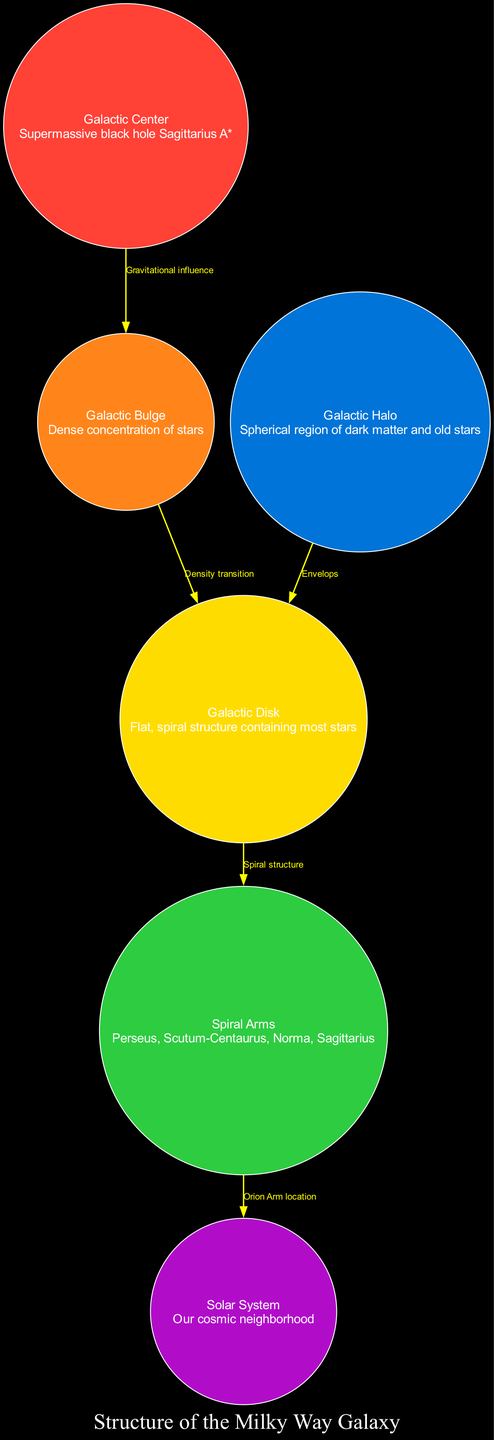What is located at the Galactic Center? The diagram indicates that the Galactic Center is home to the supermassive black hole Sagittarius A*. This information is directly included in the description of the Galactic Center node.
Answer: Sagittarius A* What is the relationship between the Galactic Bulge and the Galactic Disk? The edge between the Galactic Bulge and the Galactic Disk is labeled "Density transition," signifying a shift in star density from the bulge to the disk. This shows how the structures are connected in terms of star distribution.
Answer: Density transition How many spiral arms are indicated in the diagram? The diagram specifically lists four spiral arms: Perseus, Scutum-Centaurus, Norma, and Sagittarius. Counting these gives the total number of spiral arms present in the Milky Way structure.
Answer: Four What color represents the Galactic Halo? Referring to the color coding in the diagram, the Galactic Halo is represented in blue. This is confirmed by identifying its corresponding node color.
Answer: Blue Which component of the Milky Way contains our Solar System? According to the diagram, the Solar System is located within the Solar System node, which is specifically labeled and described as our cosmic neighborhood.
Answer: Solar System What influences the Galactic Bulge? The diagram shows an edge labeled "Gravitational influence" between the Galactic Center and the Galactic Bulge, indicating that the central black hole exerts a gravitational force affecting the bulge's structure.
Answer: Gravitational influence What effect does the Galactic Halo have on the Galactic Disk? The diagram depicts an edge labeled "Envelops" between the Galactic Halo and the Galactic Disk, indicating that the halo surrounds or contains the disk structure within the galaxy.
Answer: Envelops What interactive element allows users to explore detailed galactic regions? The diagram includes a "Zoom" interactive element that enables users to closely examine various regions of the galaxy. This feature enhances the viewing experience by providing detail about different structures and areas.
Answer: Zoom How can users obtain in-depth facts about each component? Users can access pop-up information for each component of the galaxy, as described in the interactive elements of the diagram. This feature enhances understanding by revealing additional details upon interaction.
Answer: Pop-up information 